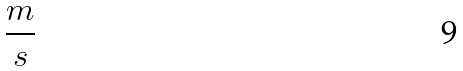<formula> <loc_0><loc_0><loc_500><loc_500>\frac { m } { s }</formula> 